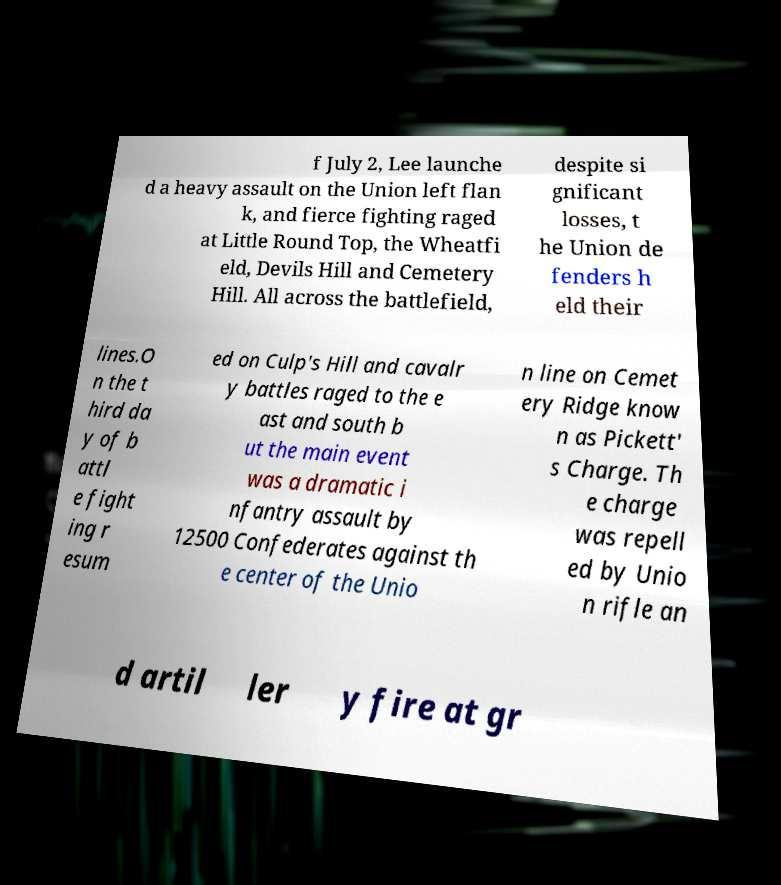What messages or text are displayed in this image? I need them in a readable, typed format. f July 2, Lee launche d a heavy assault on the Union left flan k, and fierce fighting raged at Little Round Top, the Wheatfi eld, Devils Hill and Cemetery Hill. All across the battlefield, despite si gnificant losses, t he Union de fenders h eld their lines.O n the t hird da y of b attl e fight ing r esum ed on Culp's Hill and cavalr y battles raged to the e ast and south b ut the main event was a dramatic i nfantry assault by 12500 Confederates against th e center of the Unio n line on Cemet ery Ridge know n as Pickett' s Charge. Th e charge was repell ed by Unio n rifle an d artil ler y fire at gr 